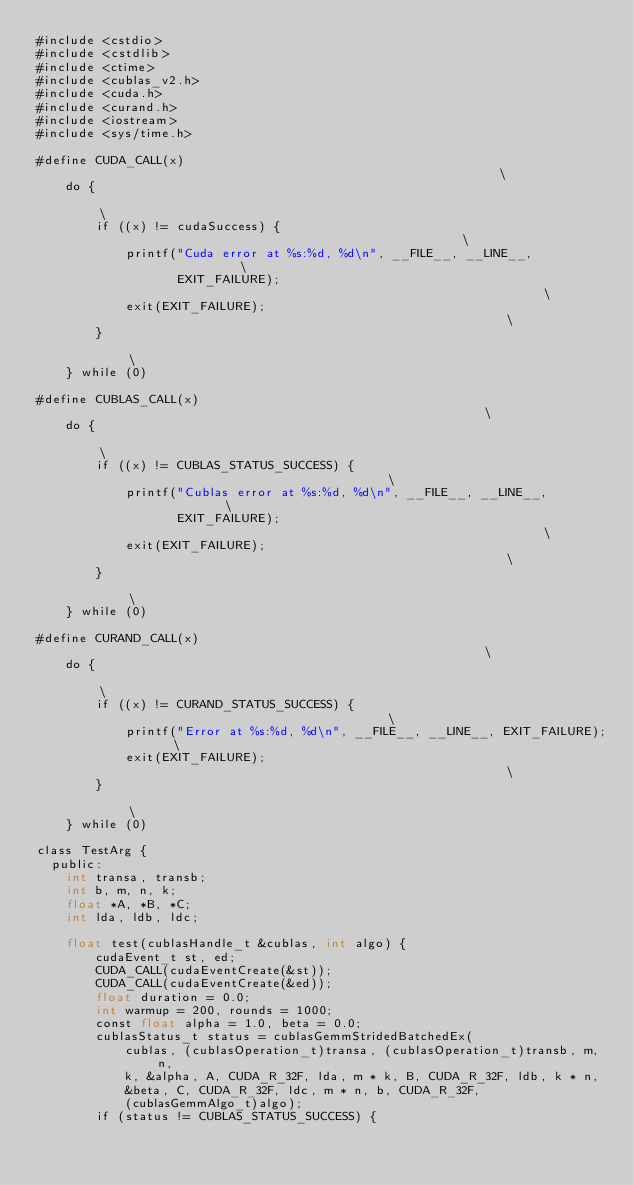Convert code to text. <code><loc_0><loc_0><loc_500><loc_500><_Cuda_>#include <cstdio>
#include <cstdlib>
#include <ctime>
#include <cublas_v2.h>
#include <cuda.h>
#include <curand.h>
#include <iostream>
#include <sys/time.h>

#define CUDA_CALL(x)                                                           \
    do {                                                                       \
        if ((x) != cudaSuccess) {                                              \
            printf("Cuda error at %s:%d, %d\n", __FILE__, __LINE__,            \
                   EXIT_FAILURE);                                              \
            exit(EXIT_FAILURE);                                                \
        }                                                                      \
    } while (0)

#define CUBLAS_CALL(x)                                                         \
    do {                                                                       \
        if ((x) != CUBLAS_STATUS_SUCCESS) {                                    \
            printf("Cublas error at %s:%d, %d\n", __FILE__, __LINE__,          \
                   EXIT_FAILURE);                                              \
            exit(EXIT_FAILURE);                                                \
        }                                                                      \
    } while (0)

#define CURAND_CALL(x)                                                         \
    do {                                                                       \
        if ((x) != CURAND_STATUS_SUCCESS) {                                    \
            printf("Error at %s:%d, %d\n", __FILE__, __LINE__, EXIT_FAILURE);  \
            exit(EXIT_FAILURE);                                                \
        }                                                                      \
    } while (0)

class TestArg {
  public:
    int transa, transb;
    int b, m, n, k;
    float *A, *B, *C;
    int lda, ldb, ldc;

    float test(cublasHandle_t &cublas, int algo) {
        cudaEvent_t st, ed;
        CUDA_CALL(cudaEventCreate(&st));
        CUDA_CALL(cudaEventCreate(&ed));
        float duration = 0.0;
        int warmup = 200, rounds = 1000;
        const float alpha = 1.0, beta = 0.0;
        cublasStatus_t status = cublasGemmStridedBatchedEx(
            cublas, (cublasOperation_t)transa, (cublasOperation_t)transb, m, n,
            k, &alpha, A, CUDA_R_32F, lda, m * k, B, CUDA_R_32F, ldb, k * n,
            &beta, C, CUDA_R_32F, ldc, m * n, b, CUDA_R_32F,
            (cublasGemmAlgo_t)algo);
        if (status != CUBLAS_STATUS_SUCCESS) {</code> 